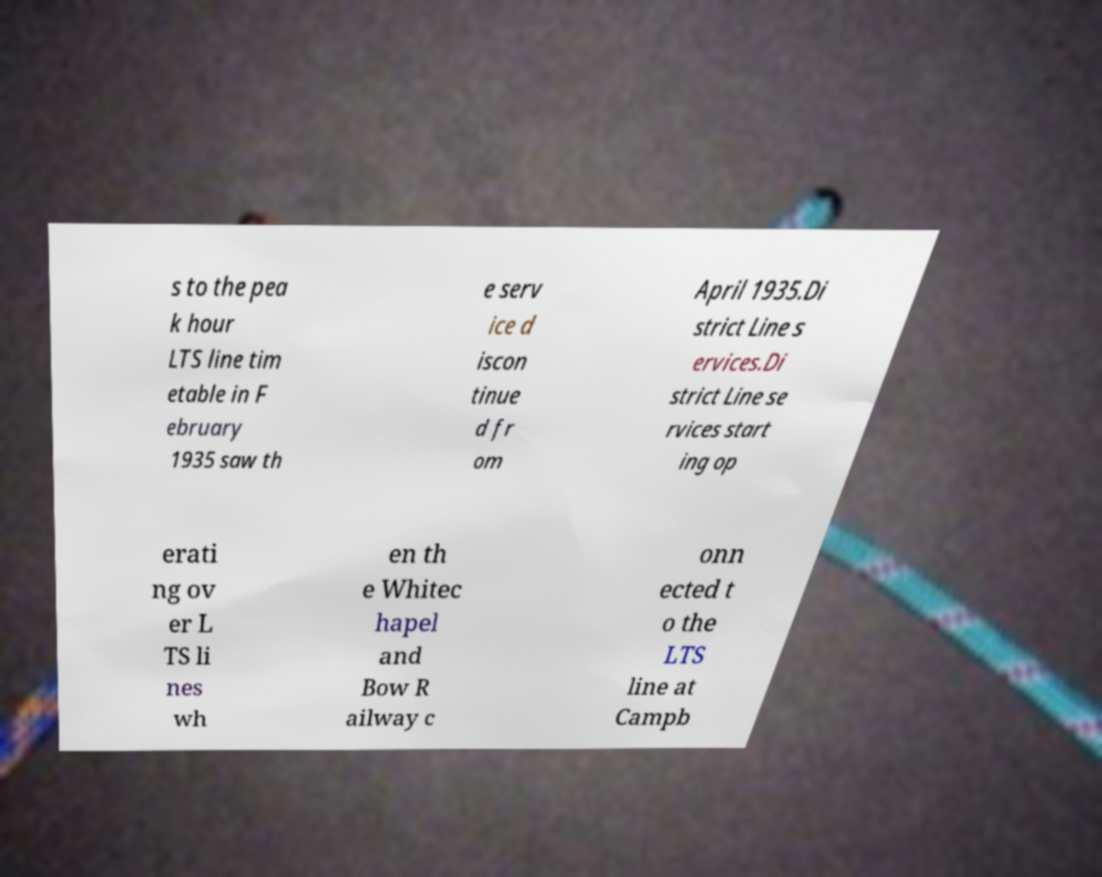Please read and relay the text visible in this image. What does it say? s to the pea k hour LTS line tim etable in F ebruary 1935 saw th e serv ice d iscon tinue d fr om April 1935.Di strict Line s ervices.Di strict Line se rvices start ing op erati ng ov er L TS li nes wh en th e Whitec hapel and Bow R ailway c onn ected t o the LTS line at Campb 